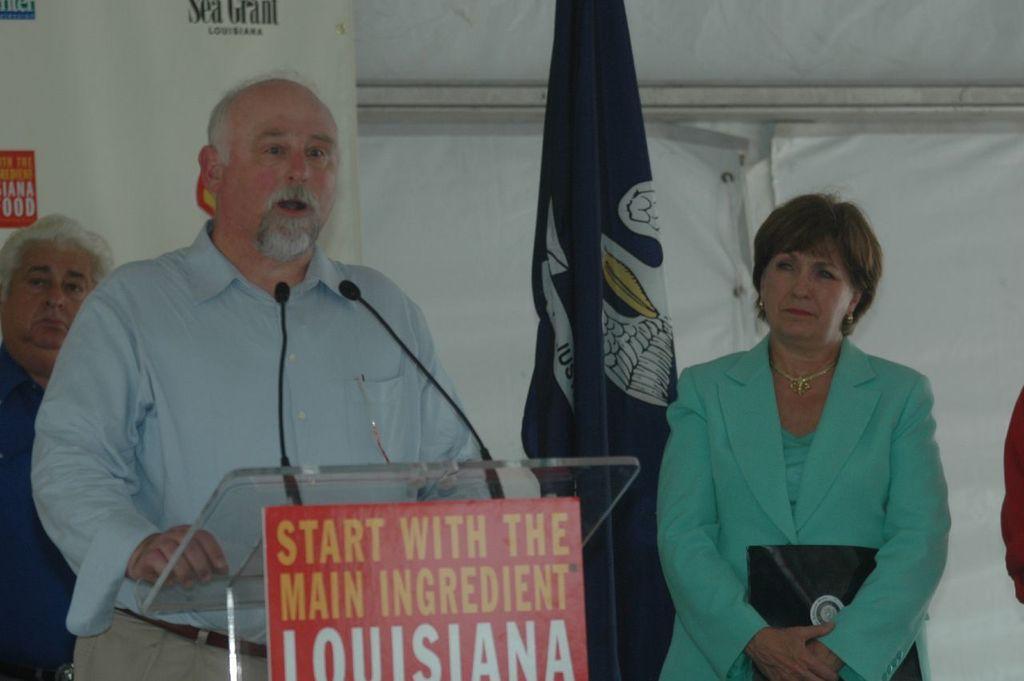Can you describe this image briefly? In this image we can see two men and one women are standing. One man is wearing blue color shirt with pant and the other man is wearing dark blue color shirt. The woman is wearing green color top with coat and holding black color thing in her hand. Beside the woman, we can see a flag. In front of the man, we can see podium and mic. We can see a banner and white color wall in the background. 